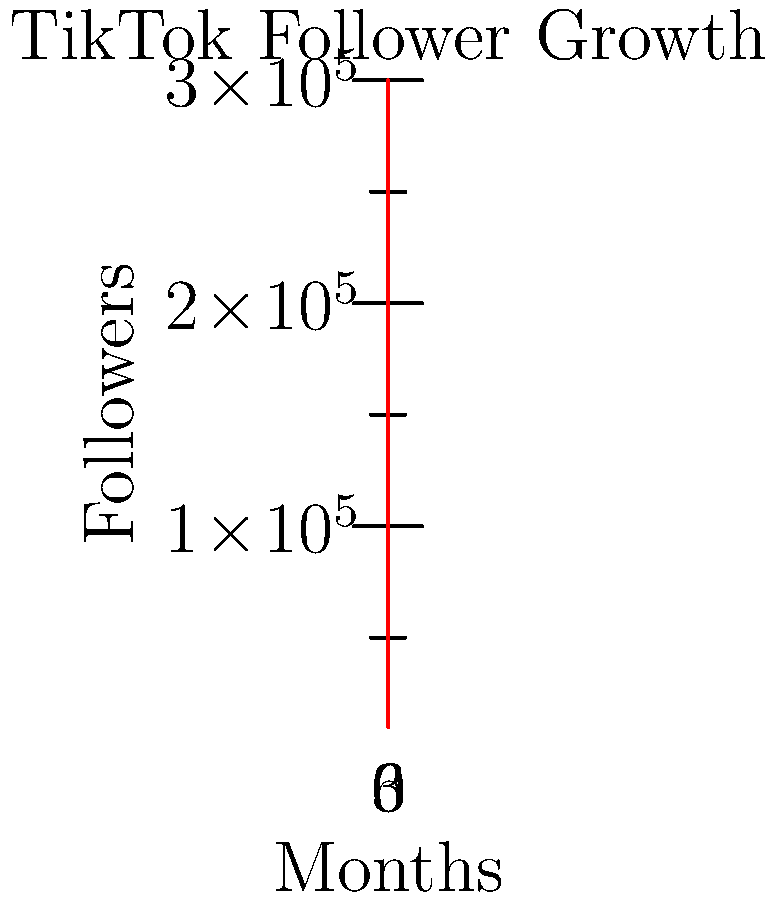Based on the graph showing your TikTok follower growth over 6 months, what was the approximate increase in followers between month 3 and month 5? To solve this problem, we need to follow these steps:

1. Identify the number of followers at month 3:
   At month 3, the follower count is approximately 50,000.

2. Identify the number of followers at month 5:
   At month 5, the follower count is approximately 180,000.

3. Calculate the difference between these two values:
   $180,000 - 50,000 = 130,000$

Therefore, the approximate increase in followers between month 3 and month 5 is 130,000.
Answer: 130,000 followers 